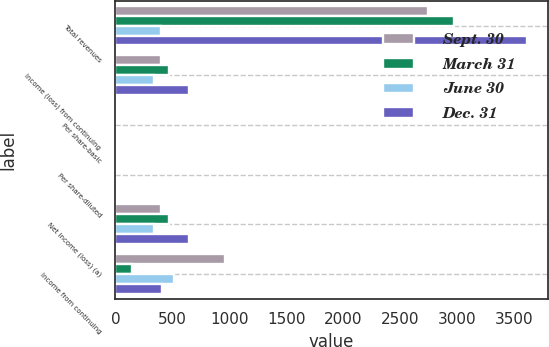<chart> <loc_0><loc_0><loc_500><loc_500><stacked_bar_chart><ecel><fcel>Total revenues<fcel>Income (loss) from continuing<fcel>Per share-basic<fcel>Per share-diluted<fcel>Net income (loss) (a)<fcel>Income from continuing<nl><fcel>Sept. 30<fcel>2743<fcel>403<fcel>2.2<fcel>0.94<fcel>403<fcel>958<nl><fcel>March 31<fcel>2970<fcel>469<fcel>0.33<fcel>1.08<fcel>468<fcel>144<nl><fcel>June 30<fcel>403<fcel>341<fcel>1<fcel>0.78<fcel>340<fcel>511<nl><fcel>Dec. 31<fcel>3612<fcel>647<fcel>0.77<fcel>1.49<fcel>647<fcel>409<nl></chart> 